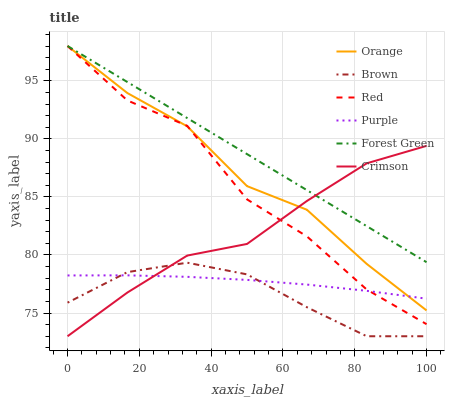Does Brown have the minimum area under the curve?
Answer yes or no. Yes. Does Forest Green have the maximum area under the curve?
Answer yes or no. Yes. Does Purple have the minimum area under the curve?
Answer yes or no. No. Does Purple have the maximum area under the curve?
Answer yes or no. No. Is Forest Green the smoothest?
Answer yes or no. Yes. Is Red the roughest?
Answer yes or no. Yes. Is Purple the smoothest?
Answer yes or no. No. Is Purple the roughest?
Answer yes or no. No. Does Brown have the lowest value?
Answer yes or no. Yes. Does Purple have the lowest value?
Answer yes or no. No. Does Red have the highest value?
Answer yes or no. Yes. Does Crimson have the highest value?
Answer yes or no. No. Is Purple less than Forest Green?
Answer yes or no. Yes. Is Red greater than Brown?
Answer yes or no. Yes. Does Crimson intersect Forest Green?
Answer yes or no. Yes. Is Crimson less than Forest Green?
Answer yes or no. No. Is Crimson greater than Forest Green?
Answer yes or no. No. Does Purple intersect Forest Green?
Answer yes or no. No. 